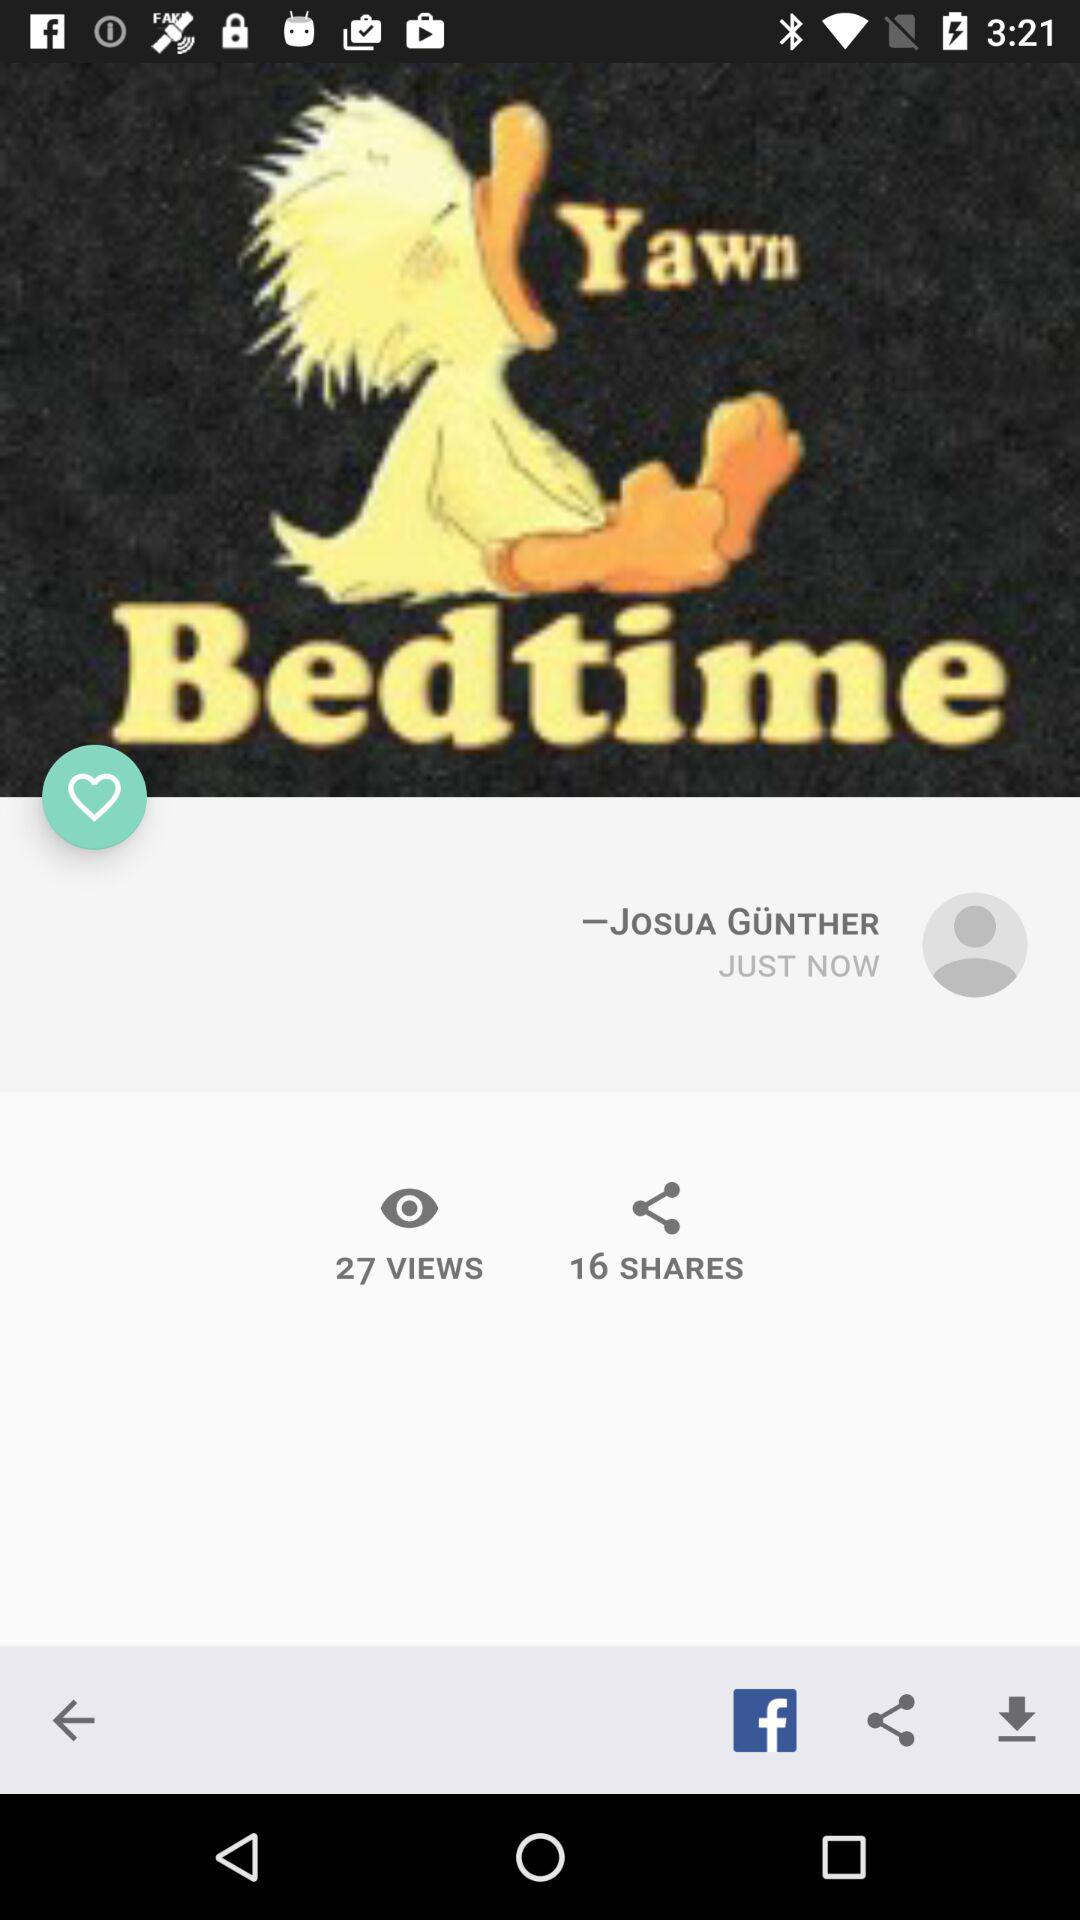When was the post updated? The post was updated just now. 